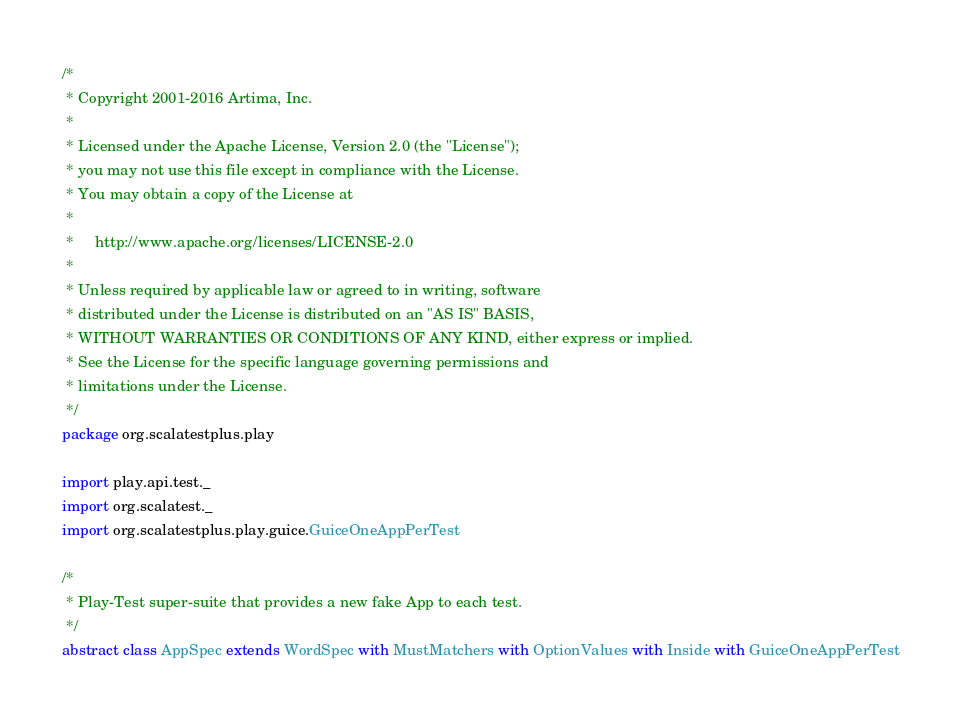Convert code to text. <code><loc_0><loc_0><loc_500><loc_500><_Scala_>/*
 * Copyright 2001-2016 Artima, Inc.
 *
 * Licensed under the Apache License, Version 2.0 (the "License");
 * you may not use this file except in compliance with the License.
 * You may obtain a copy of the License at
 *
 *     http://www.apache.org/licenses/LICENSE-2.0
 *
 * Unless required by applicable law or agreed to in writing, software
 * distributed under the License is distributed on an "AS IS" BASIS,
 * WITHOUT WARRANTIES OR CONDITIONS OF ANY KIND, either express or implied.
 * See the License for the specific language governing permissions and
 * limitations under the License.
 */
package org.scalatestplus.play

import play.api.test._
import org.scalatest._
import org.scalatestplus.play.guice.GuiceOneAppPerTest

/*
 * Play-Test super-suite that provides a new fake App to each test.
 */
abstract class AppSpec extends WordSpec with MustMatchers with OptionValues with Inside with GuiceOneAppPerTest
</code> 